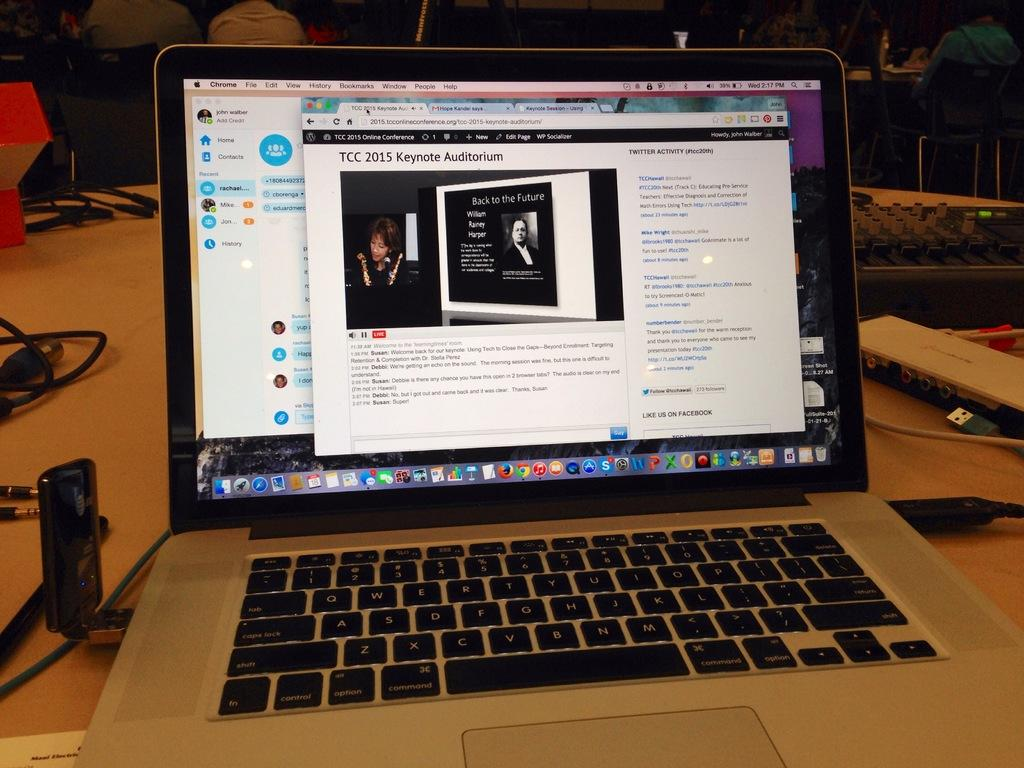<image>
Write a terse but informative summary of the picture. The laptop on the table is open to a webpage for TCC 2015 Keynote Auditorium. 